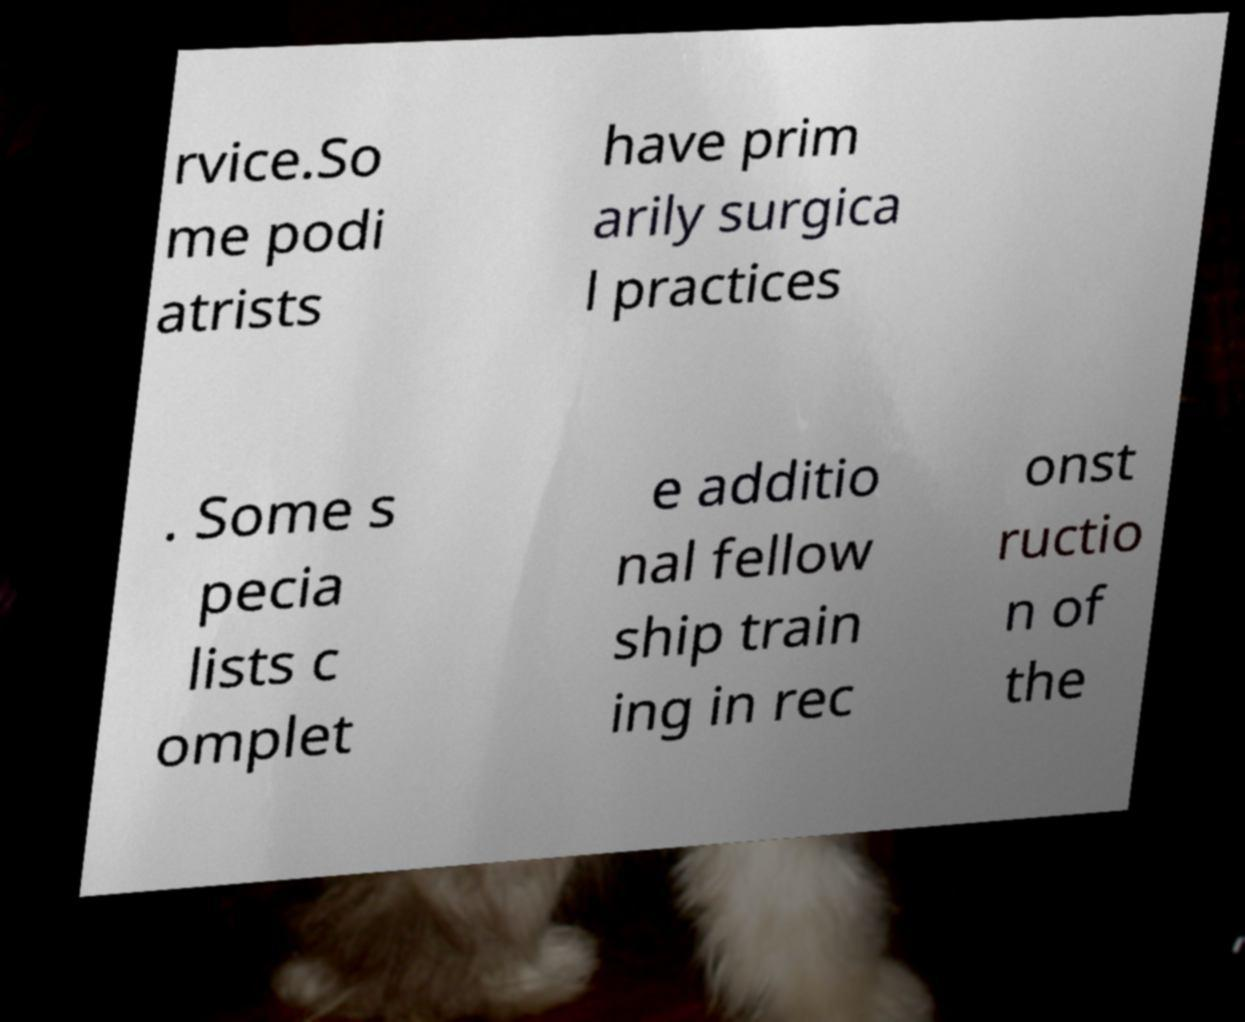I need the written content from this picture converted into text. Can you do that? rvice.So me podi atrists have prim arily surgica l practices . Some s pecia lists c omplet e additio nal fellow ship train ing in rec onst ructio n of the 